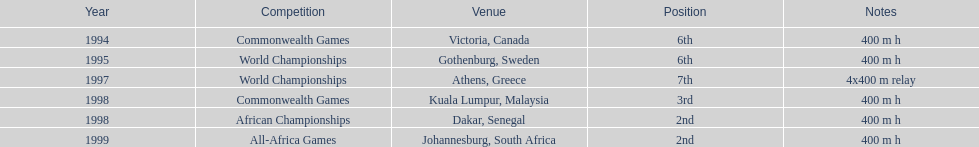On this chart, what is the cumulative number of competitions? 6. 